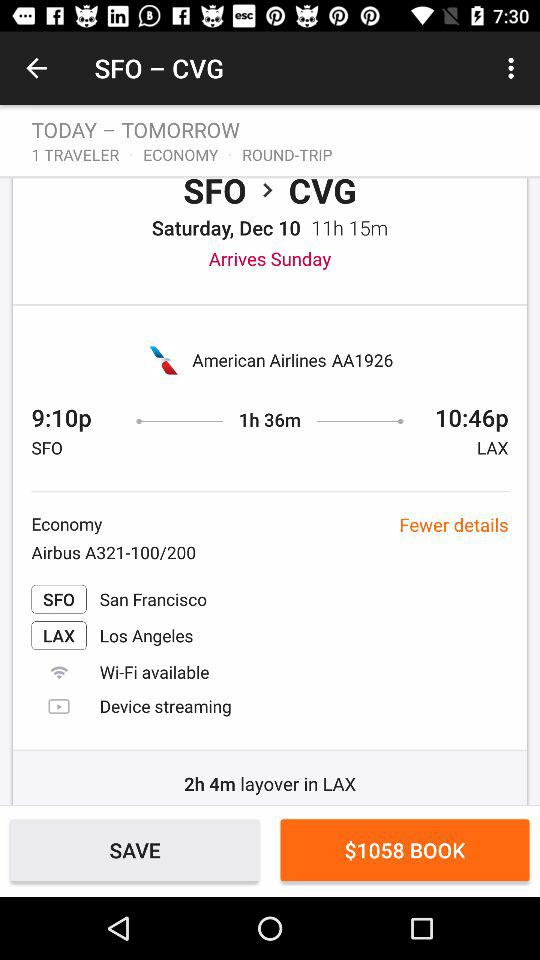What is the booking amount? The booking amount is $1058. 